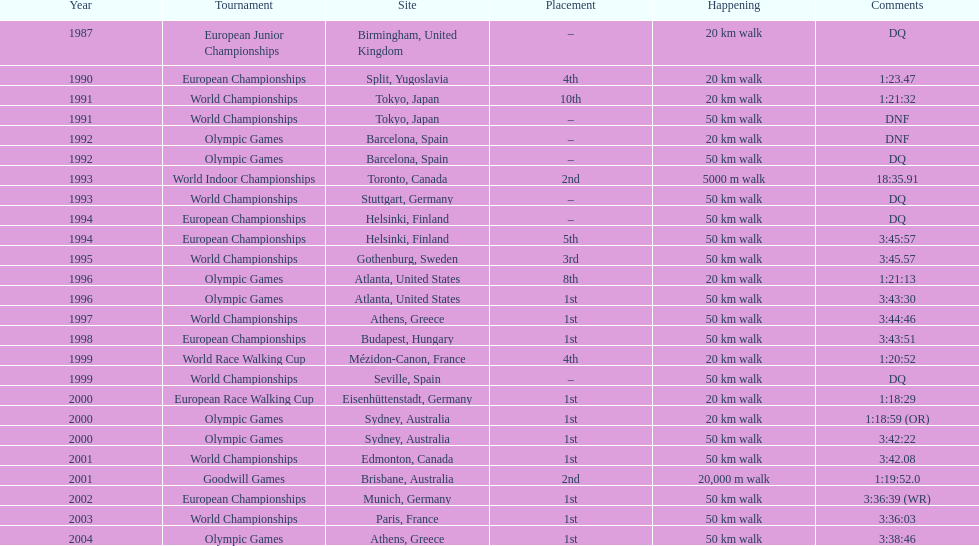What was the difference between korzeniowski's performance at the 1996 olympic games and the 2000 olympic games in the 20 km walk? 2:14. 